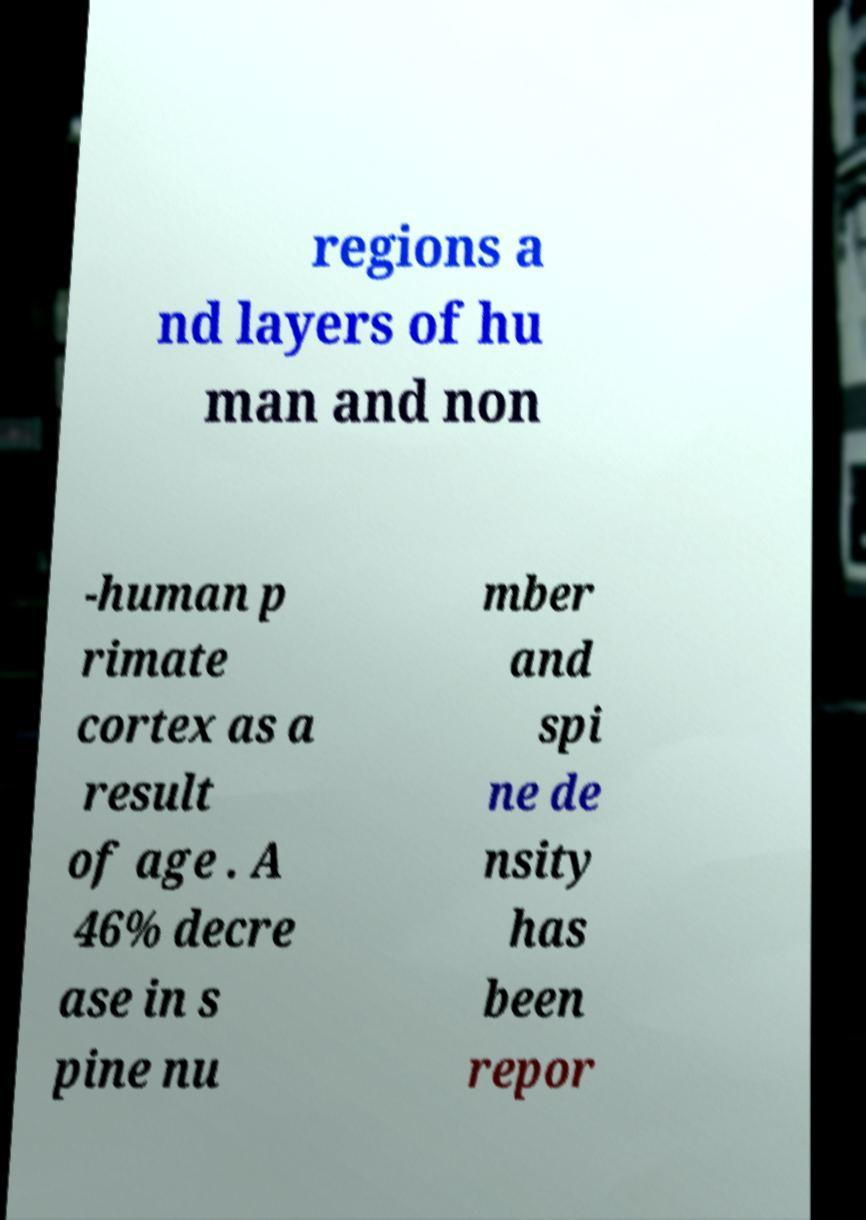Please read and relay the text visible in this image. What does it say? regions a nd layers of hu man and non -human p rimate cortex as a result of age . A 46% decre ase in s pine nu mber and spi ne de nsity has been repor 